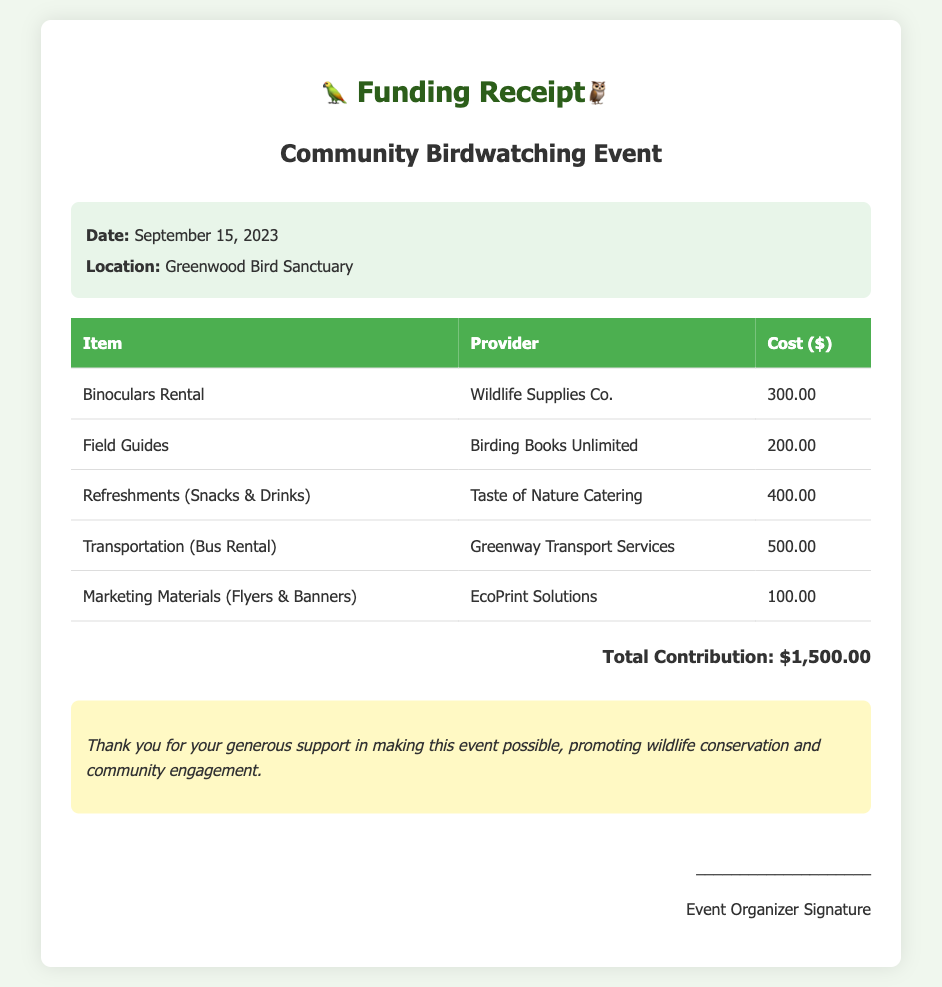What is the total amount contributed? The total amount contributed can be found in the total section of the receipt, which states $1,500.00.
Answer: $1,500.00 What is the date of the event? The date of the event is mentioned in the event details section, which is September 15, 2023.
Answer: September 15, 2023 Who provided the refreshments? The provider of the refreshments is listed in the itemized expenses, which is Taste of Nature Catering.
Answer: Taste of Nature Catering How much did the binoculars rental cost? The cost of binoculars rental is noted in the expenses table, which is $300.00.
Answer: $300.00 What type of document is this? This document serves as a funding receipt for a community birdwatching event, as indicated in the title and content.
Answer: Funding Receipt What was the location of the event? The location of the event is mentioned in the event details and is the Greenwood Bird Sanctuary.
Answer: Greenwood Bird Sanctuary How many expenses are itemized in total? The number of itemized expenses can be counted from the table, which has five distinct expenses listed.
Answer: Five What is included in the refreshments? The refreshments item specifies it includes snacks and drinks.
Answer: Snacks & Drinks 